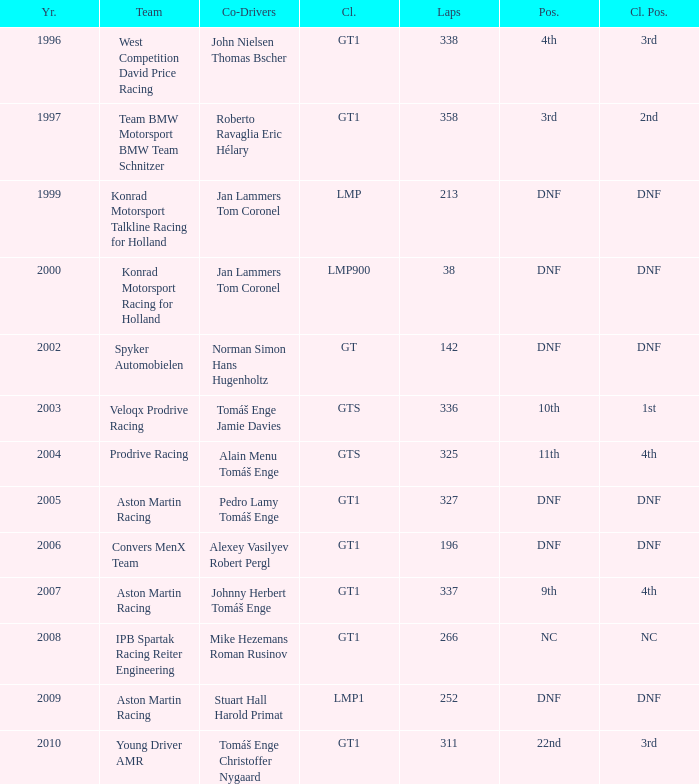Can you parse all the data within this table? {'header': ['Yr.', 'Team', 'Co-Drivers', 'Cl.', 'Laps', 'Pos.', 'Cl. Pos.'], 'rows': [['1996', 'West Competition David Price Racing', 'John Nielsen Thomas Bscher', 'GT1', '338', '4th', '3rd'], ['1997', 'Team BMW Motorsport BMW Team Schnitzer', 'Roberto Ravaglia Eric Hélary', 'GT1', '358', '3rd', '2nd'], ['1999', 'Konrad Motorsport Talkline Racing for Holland', 'Jan Lammers Tom Coronel', 'LMP', '213', 'DNF', 'DNF'], ['2000', 'Konrad Motorsport Racing for Holland', 'Jan Lammers Tom Coronel', 'LMP900', '38', 'DNF', 'DNF'], ['2002', 'Spyker Automobielen', 'Norman Simon Hans Hugenholtz', 'GT', '142', 'DNF', 'DNF'], ['2003', 'Veloqx Prodrive Racing', 'Tomáš Enge Jamie Davies', 'GTS', '336', '10th', '1st'], ['2004', 'Prodrive Racing', 'Alain Menu Tomáš Enge', 'GTS', '325', '11th', '4th'], ['2005', 'Aston Martin Racing', 'Pedro Lamy Tomáš Enge', 'GT1', '327', 'DNF', 'DNF'], ['2006', 'Convers MenX Team', 'Alexey Vasilyev Robert Pergl', 'GT1', '196', 'DNF', 'DNF'], ['2007', 'Aston Martin Racing', 'Johnny Herbert Tomáš Enge', 'GT1', '337', '9th', '4th'], ['2008', 'IPB Spartak Racing Reiter Engineering', 'Mike Hezemans Roman Rusinov', 'GT1', '266', 'NC', 'NC'], ['2009', 'Aston Martin Racing', 'Stuart Hall Harold Primat', 'LMP1', '252', 'DNF', 'DNF'], ['2010', 'Young Driver AMR', 'Tomáš Enge Christoffer Nygaard', 'GT1', '311', '22nd', '3rd']]} Which team finished 3rd in class with 337 laps before 2008? West Competition David Price Racing. 